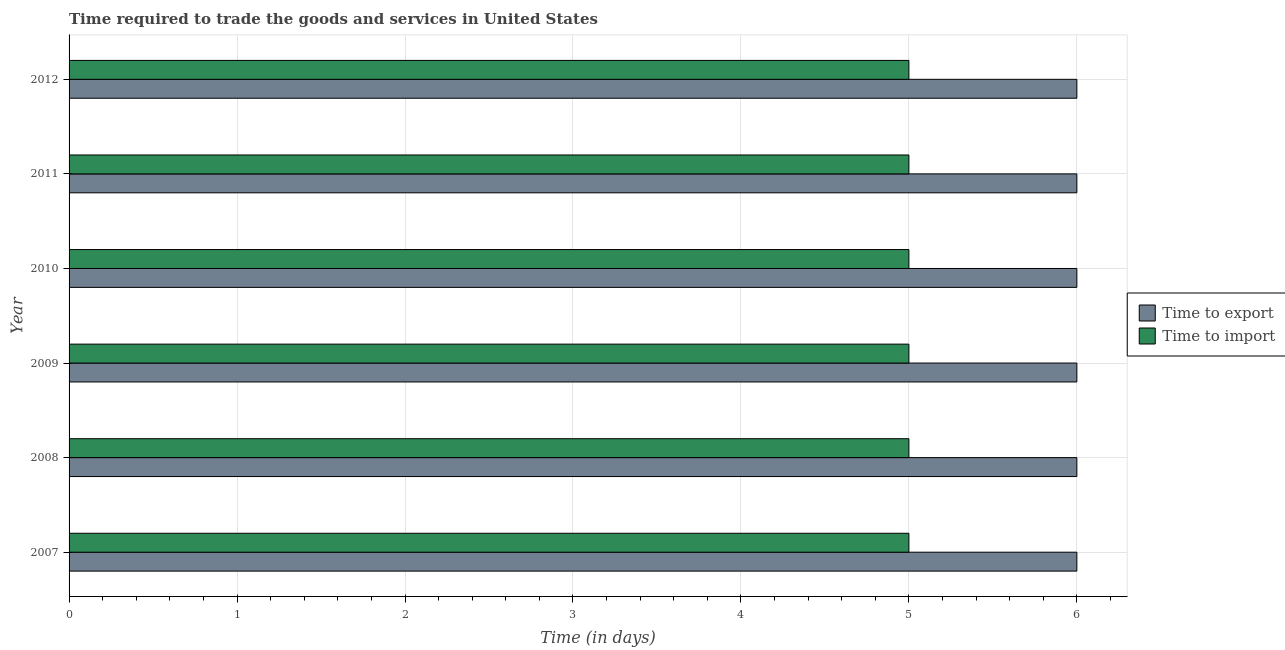How many groups of bars are there?
Your answer should be very brief. 6. Are the number of bars per tick equal to the number of legend labels?
Provide a succinct answer. Yes. Are the number of bars on each tick of the Y-axis equal?
Provide a short and direct response. Yes. How many bars are there on the 6th tick from the top?
Provide a short and direct response. 2. How many bars are there on the 1st tick from the bottom?
Your answer should be compact. 2. What is the time to export in 2009?
Offer a very short reply. 6. Across all years, what is the maximum time to export?
Ensure brevity in your answer.  6. Across all years, what is the minimum time to export?
Provide a succinct answer. 6. In which year was the time to export maximum?
Make the answer very short. 2007. In which year was the time to export minimum?
Give a very brief answer. 2007. What is the total time to import in the graph?
Offer a terse response. 30. What is the average time to export per year?
Your response must be concise. 6. In how many years, is the time to import greater than 0.4 days?
Provide a succinct answer. 6. Is the time to export in 2007 less than that in 2011?
Ensure brevity in your answer.  No. In how many years, is the time to export greater than the average time to export taken over all years?
Your response must be concise. 0. What does the 1st bar from the top in 2009 represents?
Make the answer very short. Time to import. What does the 1st bar from the bottom in 2008 represents?
Offer a terse response. Time to export. Are all the bars in the graph horizontal?
Your answer should be compact. Yes. How many years are there in the graph?
Provide a succinct answer. 6. What is the difference between two consecutive major ticks on the X-axis?
Your answer should be compact. 1. Does the graph contain grids?
Your answer should be compact. Yes. Where does the legend appear in the graph?
Provide a succinct answer. Center right. How are the legend labels stacked?
Provide a succinct answer. Vertical. What is the title of the graph?
Provide a succinct answer. Time required to trade the goods and services in United States. What is the label or title of the X-axis?
Offer a terse response. Time (in days). What is the Time (in days) of Time to export in 2010?
Your response must be concise. 6. What is the Time (in days) in Time to import in 2010?
Your answer should be very brief. 5. What is the Time (in days) in Time to import in 2011?
Your answer should be very brief. 5. What is the Time (in days) of Time to export in 2012?
Ensure brevity in your answer.  6. What is the Time (in days) in Time to import in 2012?
Give a very brief answer. 5. Across all years, what is the maximum Time (in days) in Time to export?
Offer a terse response. 6. Across all years, what is the maximum Time (in days) of Time to import?
Provide a short and direct response. 5. What is the total Time (in days) in Time to export in the graph?
Make the answer very short. 36. What is the difference between the Time (in days) of Time to export in 2007 and that in 2008?
Offer a terse response. 0. What is the difference between the Time (in days) of Time to import in 2007 and that in 2008?
Offer a terse response. 0. What is the difference between the Time (in days) of Time to import in 2007 and that in 2010?
Your answer should be compact. 0. What is the difference between the Time (in days) of Time to import in 2007 and that in 2011?
Your response must be concise. 0. What is the difference between the Time (in days) of Time to export in 2008 and that in 2010?
Give a very brief answer. 0. What is the difference between the Time (in days) of Time to import in 2008 and that in 2010?
Your answer should be very brief. 0. What is the difference between the Time (in days) in Time to export in 2008 and that in 2012?
Your answer should be very brief. 0. What is the difference between the Time (in days) in Time to import in 2008 and that in 2012?
Make the answer very short. 0. What is the difference between the Time (in days) in Time to import in 2009 and that in 2010?
Your answer should be compact. 0. What is the difference between the Time (in days) in Time to import in 2009 and that in 2011?
Keep it short and to the point. 0. What is the difference between the Time (in days) of Time to import in 2009 and that in 2012?
Provide a short and direct response. 0. What is the difference between the Time (in days) of Time to export in 2010 and that in 2011?
Your answer should be very brief. 0. What is the difference between the Time (in days) in Time to import in 2010 and that in 2011?
Make the answer very short. 0. What is the difference between the Time (in days) in Time to import in 2010 and that in 2012?
Offer a terse response. 0. What is the difference between the Time (in days) of Time to export in 2008 and the Time (in days) of Time to import in 2009?
Make the answer very short. 1. What is the difference between the Time (in days) in Time to export in 2008 and the Time (in days) in Time to import in 2010?
Make the answer very short. 1. What is the difference between the Time (in days) in Time to export in 2008 and the Time (in days) in Time to import in 2012?
Keep it short and to the point. 1. What is the difference between the Time (in days) in Time to export in 2009 and the Time (in days) in Time to import in 2011?
Your answer should be very brief. 1. What is the difference between the Time (in days) of Time to export in 2010 and the Time (in days) of Time to import in 2011?
Keep it short and to the point. 1. What is the average Time (in days) of Time to export per year?
Keep it short and to the point. 6. In the year 2007, what is the difference between the Time (in days) of Time to export and Time (in days) of Time to import?
Your response must be concise. 1. In the year 2009, what is the difference between the Time (in days) of Time to export and Time (in days) of Time to import?
Provide a short and direct response. 1. In the year 2010, what is the difference between the Time (in days) of Time to export and Time (in days) of Time to import?
Keep it short and to the point. 1. What is the ratio of the Time (in days) in Time to export in 2007 to that in 2009?
Offer a terse response. 1. What is the ratio of the Time (in days) of Time to export in 2007 to that in 2010?
Offer a terse response. 1. What is the ratio of the Time (in days) in Time to export in 2007 to that in 2011?
Keep it short and to the point. 1. What is the ratio of the Time (in days) of Time to import in 2007 to that in 2011?
Offer a terse response. 1. What is the ratio of the Time (in days) in Time to export in 2007 to that in 2012?
Give a very brief answer. 1. What is the ratio of the Time (in days) in Time to import in 2007 to that in 2012?
Make the answer very short. 1. What is the ratio of the Time (in days) of Time to export in 2008 to that in 2009?
Ensure brevity in your answer.  1. What is the ratio of the Time (in days) in Time to import in 2008 to that in 2009?
Offer a very short reply. 1. What is the ratio of the Time (in days) of Time to export in 2008 to that in 2010?
Provide a short and direct response. 1. What is the ratio of the Time (in days) in Time to import in 2008 to that in 2010?
Make the answer very short. 1. What is the ratio of the Time (in days) in Time to import in 2008 to that in 2012?
Provide a short and direct response. 1. What is the ratio of the Time (in days) of Time to export in 2009 to that in 2010?
Your answer should be very brief. 1. What is the ratio of the Time (in days) of Time to export in 2009 to that in 2011?
Keep it short and to the point. 1. What is the ratio of the Time (in days) in Time to export in 2010 to that in 2012?
Offer a terse response. 1. What is the ratio of the Time (in days) of Time to import in 2010 to that in 2012?
Offer a terse response. 1. What is the difference between the highest and the second highest Time (in days) in Time to import?
Ensure brevity in your answer.  0. What is the difference between the highest and the lowest Time (in days) in Time to export?
Keep it short and to the point. 0. What is the difference between the highest and the lowest Time (in days) in Time to import?
Your answer should be very brief. 0. 